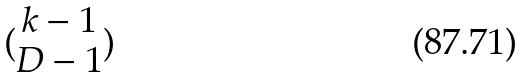Convert formula to latex. <formula><loc_0><loc_0><loc_500><loc_500>( \begin{matrix} k - 1 \\ D - 1 \end{matrix} )</formula> 